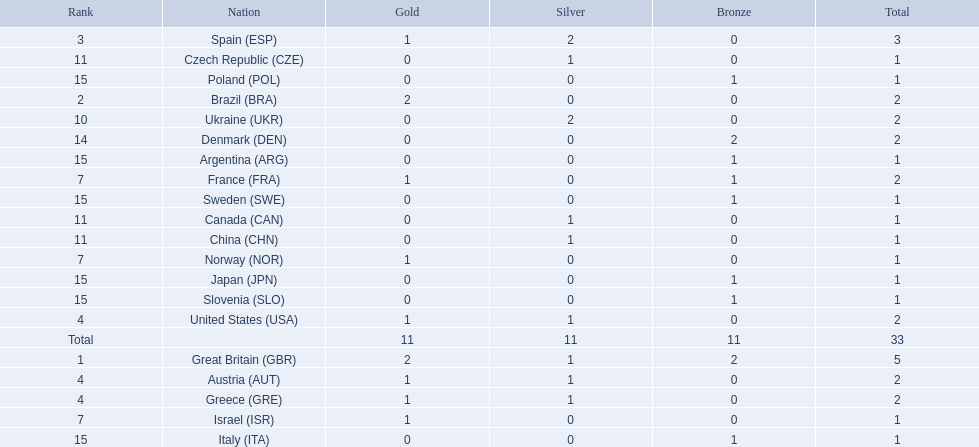How many medals did spain gain 3. Only country that got more medals? Spain (ESP). 